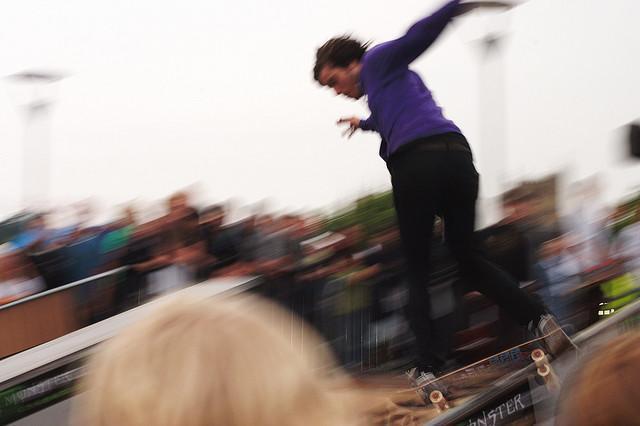How many people are there?
Give a very brief answer. 4. 